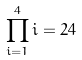<formula> <loc_0><loc_0><loc_500><loc_500>\prod _ { i = 1 } ^ { 4 } i = 2 4</formula> 